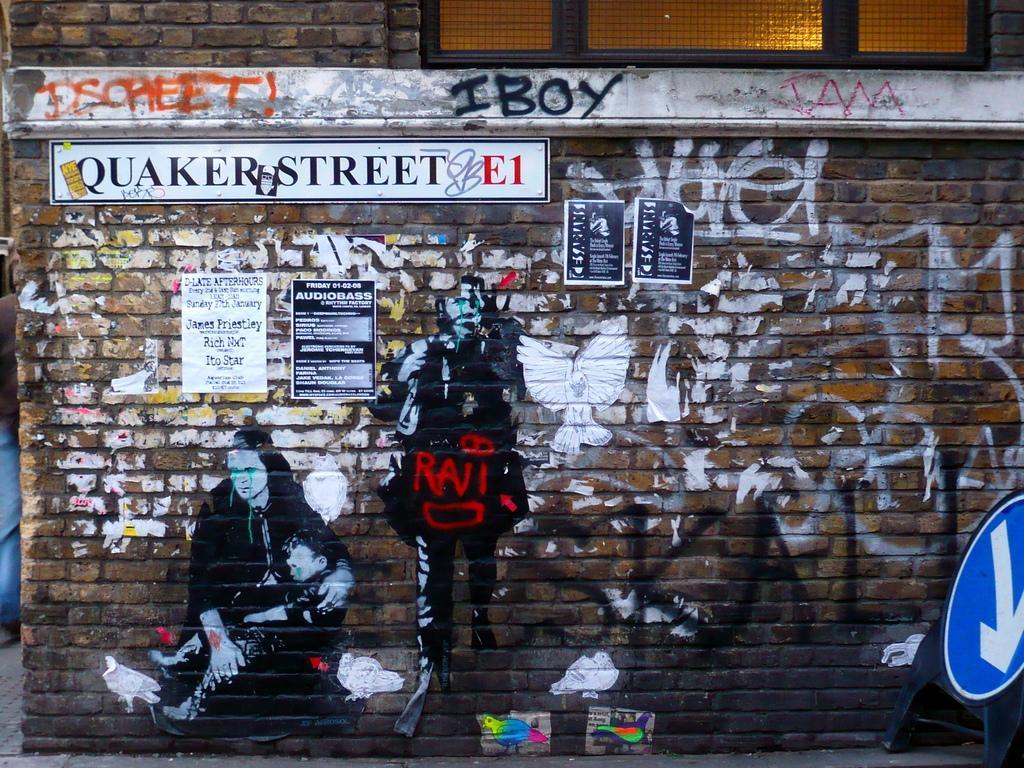Could you give a brief overview of what you see in this image? In this picture I can see posts attached to the wall and there are paintings on the wall. There are boards and some other objects. 